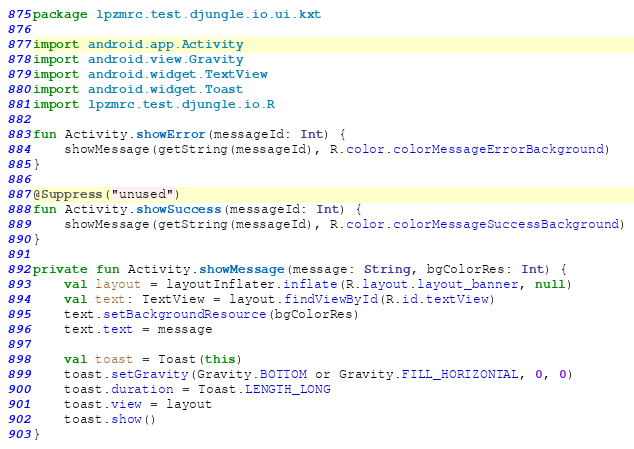Convert code to text. <code><loc_0><loc_0><loc_500><loc_500><_Kotlin_>package lpzmrc.test.djungle.io.ui.kxt

import android.app.Activity
import android.view.Gravity
import android.widget.TextView
import android.widget.Toast
import lpzmrc.test.djungle.io.R

fun Activity.showError(messageId: Int) {
    showMessage(getString(messageId), R.color.colorMessageErrorBackground)
}

@Suppress("unused")
fun Activity.showSuccess(messageId: Int) {
    showMessage(getString(messageId), R.color.colorMessageSuccessBackground)
}

private fun Activity.showMessage(message: String, bgColorRes: Int) {
    val layout = layoutInflater.inflate(R.layout.layout_banner, null)
    val text: TextView = layout.findViewById(R.id.textView)
    text.setBackgroundResource(bgColorRes)
    text.text = message

    val toast = Toast(this)
    toast.setGravity(Gravity.BOTTOM or Gravity.FILL_HORIZONTAL, 0, 0)
    toast.duration = Toast.LENGTH_LONG
    toast.view = layout
    toast.show()
}</code> 